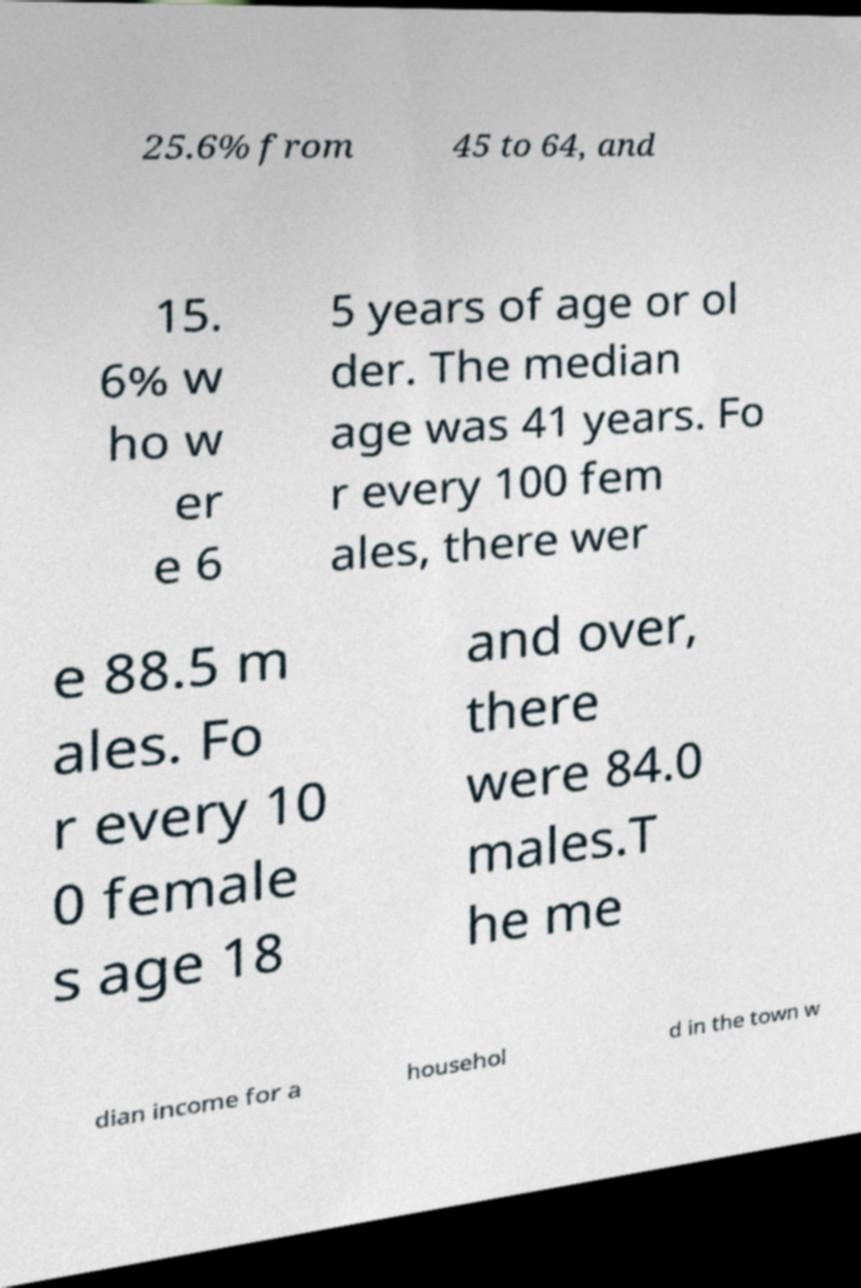I need the written content from this picture converted into text. Can you do that? 25.6% from 45 to 64, and 15. 6% w ho w er e 6 5 years of age or ol der. The median age was 41 years. Fo r every 100 fem ales, there wer e 88.5 m ales. Fo r every 10 0 female s age 18 and over, there were 84.0 males.T he me dian income for a househol d in the town w 